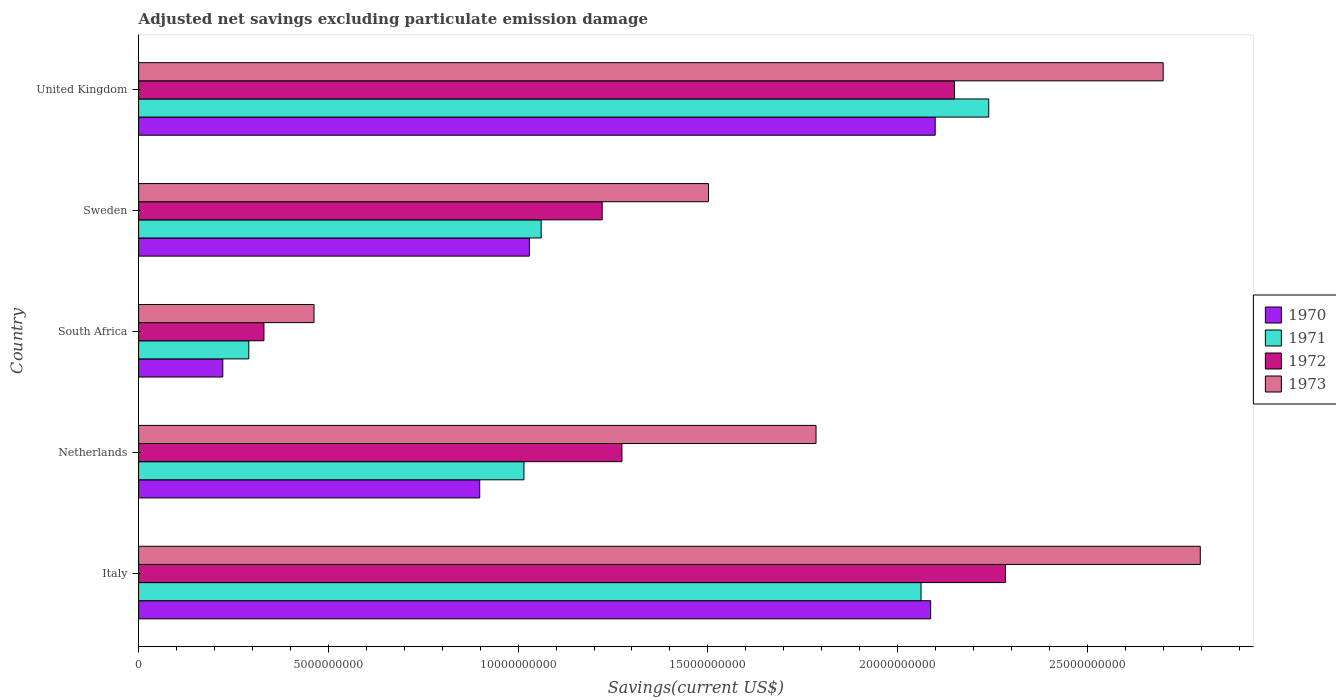How many groups of bars are there?
Give a very brief answer. 5. How many bars are there on the 5th tick from the bottom?
Keep it short and to the point. 4. What is the label of the 2nd group of bars from the top?
Make the answer very short. Sweden. In how many cases, is the number of bars for a given country not equal to the number of legend labels?
Your answer should be compact. 0. What is the adjusted net savings in 1970 in Sweden?
Your answer should be compact. 1.03e+1. Across all countries, what is the maximum adjusted net savings in 1970?
Your response must be concise. 2.10e+1. Across all countries, what is the minimum adjusted net savings in 1971?
Provide a short and direct response. 2.90e+09. In which country was the adjusted net savings in 1972 minimum?
Your response must be concise. South Africa. What is the total adjusted net savings in 1972 in the graph?
Make the answer very short. 7.26e+1. What is the difference between the adjusted net savings in 1970 in Netherlands and that in United Kingdom?
Your answer should be very brief. -1.20e+1. What is the difference between the adjusted net savings in 1970 in Sweden and the adjusted net savings in 1971 in Netherlands?
Make the answer very short. 1.43e+08. What is the average adjusted net savings in 1973 per country?
Your answer should be very brief. 1.85e+1. What is the difference between the adjusted net savings in 1971 and adjusted net savings in 1973 in United Kingdom?
Your response must be concise. -4.60e+09. In how many countries, is the adjusted net savings in 1973 greater than 10000000000 US$?
Provide a succinct answer. 4. What is the ratio of the adjusted net savings in 1970 in Netherlands to that in Sweden?
Offer a terse response. 0.87. Is the adjusted net savings in 1971 in Italy less than that in Netherlands?
Ensure brevity in your answer.  No. What is the difference between the highest and the second highest adjusted net savings in 1973?
Your answer should be compact. 9.78e+08. What is the difference between the highest and the lowest adjusted net savings in 1972?
Your answer should be very brief. 1.95e+1. Is the sum of the adjusted net savings in 1973 in Sweden and United Kingdom greater than the maximum adjusted net savings in 1970 across all countries?
Your answer should be very brief. Yes. What does the 3rd bar from the bottom in Italy represents?
Keep it short and to the point. 1972. How many bars are there?
Keep it short and to the point. 20. How many countries are there in the graph?
Ensure brevity in your answer.  5. What is the difference between two consecutive major ticks on the X-axis?
Your response must be concise. 5.00e+09. Does the graph contain grids?
Keep it short and to the point. No. What is the title of the graph?
Keep it short and to the point. Adjusted net savings excluding particulate emission damage. What is the label or title of the X-axis?
Your answer should be very brief. Savings(current US$). What is the label or title of the Y-axis?
Offer a terse response. Country. What is the Savings(current US$) in 1970 in Italy?
Make the answer very short. 2.09e+1. What is the Savings(current US$) of 1971 in Italy?
Offer a terse response. 2.06e+1. What is the Savings(current US$) in 1972 in Italy?
Your response must be concise. 2.28e+1. What is the Savings(current US$) in 1973 in Italy?
Ensure brevity in your answer.  2.80e+1. What is the Savings(current US$) in 1970 in Netherlands?
Offer a terse response. 8.99e+09. What is the Savings(current US$) of 1971 in Netherlands?
Ensure brevity in your answer.  1.02e+1. What is the Savings(current US$) in 1972 in Netherlands?
Give a very brief answer. 1.27e+1. What is the Savings(current US$) in 1973 in Netherlands?
Provide a short and direct response. 1.79e+1. What is the Savings(current US$) of 1970 in South Africa?
Offer a very short reply. 2.22e+09. What is the Savings(current US$) in 1971 in South Africa?
Provide a short and direct response. 2.90e+09. What is the Savings(current US$) of 1972 in South Africa?
Provide a succinct answer. 3.30e+09. What is the Savings(current US$) in 1973 in South Africa?
Your answer should be very brief. 4.62e+09. What is the Savings(current US$) of 1970 in Sweden?
Your answer should be very brief. 1.03e+1. What is the Savings(current US$) of 1971 in Sweden?
Offer a very short reply. 1.06e+1. What is the Savings(current US$) in 1972 in Sweden?
Keep it short and to the point. 1.22e+1. What is the Savings(current US$) of 1973 in Sweden?
Provide a short and direct response. 1.50e+1. What is the Savings(current US$) of 1970 in United Kingdom?
Provide a short and direct response. 2.10e+1. What is the Savings(current US$) of 1971 in United Kingdom?
Offer a very short reply. 2.24e+1. What is the Savings(current US$) in 1972 in United Kingdom?
Your answer should be very brief. 2.15e+1. What is the Savings(current US$) in 1973 in United Kingdom?
Your answer should be very brief. 2.70e+1. Across all countries, what is the maximum Savings(current US$) in 1970?
Give a very brief answer. 2.10e+1. Across all countries, what is the maximum Savings(current US$) of 1971?
Your answer should be very brief. 2.24e+1. Across all countries, what is the maximum Savings(current US$) of 1972?
Make the answer very short. 2.28e+1. Across all countries, what is the maximum Savings(current US$) in 1973?
Your answer should be compact. 2.80e+1. Across all countries, what is the minimum Savings(current US$) in 1970?
Offer a terse response. 2.22e+09. Across all countries, what is the minimum Savings(current US$) in 1971?
Give a very brief answer. 2.90e+09. Across all countries, what is the minimum Savings(current US$) in 1972?
Provide a short and direct response. 3.30e+09. Across all countries, what is the minimum Savings(current US$) of 1973?
Keep it short and to the point. 4.62e+09. What is the total Savings(current US$) of 1970 in the graph?
Provide a succinct answer. 6.34e+1. What is the total Savings(current US$) in 1971 in the graph?
Offer a terse response. 6.67e+1. What is the total Savings(current US$) in 1972 in the graph?
Provide a succinct answer. 7.26e+1. What is the total Savings(current US$) of 1973 in the graph?
Give a very brief answer. 9.25e+1. What is the difference between the Savings(current US$) in 1970 in Italy and that in Netherlands?
Provide a succinct answer. 1.19e+1. What is the difference between the Savings(current US$) of 1971 in Italy and that in Netherlands?
Your response must be concise. 1.05e+1. What is the difference between the Savings(current US$) in 1972 in Italy and that in Netherlands?
Your response must be concise. 1.01e+1. What is the difference between the Savings(current US$) of 1973 in Italy and that in Netherlands?
Provide a succinct answer. 1.01e+1. What is the difference between the Savings(current US$) in 1970 in Italy and that in South Africa?
Keep it short and to the point. 1.87e+1. What is the difference between the Savings(current US$) in 1971 in Italy and that in South Africa?
Give a very brief answer. 1.77e+1. What is the difference between the Savings(current US$) in 1972 in Italy and that in South Africa?
Your answer should be very brief. 1.95e+1. What is the difference between the Savings(current US$) of 1973 in Italy and that in South Africa?
Offer a very short reply. 2.34e+1. What is the difference between the Savings(current US$) in 1970 in Italy and that in Sweden?
Provide a succinct answer. 1.06e+1. What is the difference between the Savings(current US$) in 1971 in Italy and that in Sweden?
Provide a succinct answer. 1.00e+1. What is the difference between the Savings(current US$) in 1972 in Italy and that in Sweden?
Make the answer very short. 1.06e+1. What is the difference between the Savings(current US$) of 1973 in Italy and that in Sweden?
Provide a short and direct response. 1.30e+1. What is the difference between the Savings(current US$) of 1970 in Italy and that in United Kingdom?
Make the answer very short. -1.20e+08. What is the difference between the Savings(current US$) of 1971 in Italy and that in United Kingdom?
Your answer should be compact. -1.78e+09. What is the difference between the Savings(current US$) of 1972 in Italy and that in United Kingdom?
Your response must be concise. 1.34e+09. What is the difference between the Savings(current US$) of 1973 in Italy and that in United Kingdom?
Provide a succinct answer. 9.78e+08. What is the difference between the Savings(current US$) in 1970 in Netherlands and that in South Africa?
Give a very brief answer. 6.77e+09. What is the difference between the Savings(current US$) in 1971 in Netherlands and that in South Africa?
Provide a short and direct response. 7.25e+09. What is the difference between the Savings(current US$) in 1972 in Netherlands and that in South Africa?
Your response must be concise. 9.43e+09. What is the difference between the Savings(current US$) of 1973 in Netherlands and that in South Africa?
Offer a very short reply. 1.32e+1. What is the difference between the Savings(current US$) in 1970 in Netherlands and that in Sweden?
Give a very brief answer. -1.31e+09. What is the difference between the Savings(current US$) in 1971 in Netherlands and that in Sweden?
Ensure brevity in your answer.  -4.54e+08. What is the difference between the Savings(current US$) in 1972 in Netherlands and that in Sweden?
Your response must be concise. 5.20e+08. What is the difference between the Savings(current US$) in 1973 in Netherlands and that in Sweden?
Ensure brevity in your answer.  2.83e+09. What is the difference between the Savings(current US$) in 1970 in Netherlands and that in United Kingdom?
Your answer should be very brief. -1.20e+1. What is the difference between the Savings(current US$) in 1971 in Netherlands and that in United Kingdom?
Your answer should be very brief. -1.22e+1. What is the difference between the Savings(current US$) in 1972 in Netherlands and that in United Kingdom?
Your answer should be very brief. -8.76e+09. What is the difference between the Savings(current US$) in 1973 in Netherlands and that in United Kingdom?
Your response must be concise. -9.15e+09. What is the difference between the Savings(current US$) of 1970 in South Africa and that in Sweden?
Give a very brief answer. -8.08e+09. What is the difference between the Savings(current US$) of 1971 in South Africa and that in Sweden?
Ensure brevity in your answer.  -7.70e+09. What is the difference between the Savings(current US$) in 1972 in South Africa and that in Sweden?
Give a very brief answer. -8.91e+09. What is the difference between the Savings(current US$) in 1973 in South Africa and that in Sweden?
Your response must be concise. -1.04e+1. What is the difference between the Savings(current US$) of 1970 in South Africa and that in United Kingdom?
Give a very brief answer. -1.88e+1. What is the difference between the Savings(current US$) of 1971 in South Africa and that in United Kingdom?
Keep it short and to the point. -1.95e+1. What is the difference between the Savings(current US$) in 1972 in South Africa and that in United Kingdom?
Provide a succinct answer. -1.82e+1. What is the difference between the Savings(current US$) of 1973 in South Africa and that in United Kingdom?
Your answer should be very brief. -2.24e+1. What is the difference between the Savings(current US$) in 1970 in Sweden and that in United Kingdom?
Keep it short and to the point. -1.07e+1. What is the difference between the Savings(current US$) in 1971 in Sweden and that in United Kingdom?
Give a very brief answer. -1.18e+1. What is the difference between the Savings(current US$) in 1972 in Sweden and that in United Kingdom?
Ensure brevity in your answer.  -9.28e+09. What is the difference between the Savings(current US$) of 1973 in Sweden and that in United Kingdom?
Provide a short and direct response. -1.20e+1. What is the difference between the Savings(current US$) in 1970 in Italy and the Savings(current US$) in 1971 in Netherlands?
Make the answer very short. 1.07e+1. What is the difference between the Savings(current US$) of 1970 in Italy and the Savings(current US$) of 1972 in Netherlands?
Your response must be concise. 8.14e+09. What is the difference between the Savings(current US$) of 1970 in Italy and the Savings(current US$) of 1973 in Netherlands?
Provide a short and direct response. 3.02e+09. What is the difference between the Savings(current US$) in 1971 in Italy and the Savings(current US$) in 1972 in Netherlands?
Offer a very short reply. 7.88e+09. What is the difference between the Savings(current US$) of 1971 in Italy and the Savings(current US$) of 1973 in Netherlands?
Provide a succinct answer. 2.77e+09. What is the difference between the Savings(current US$) in 1972 in Italy and the Savings(current US$) in 1973 in Netherlands?
Ensure brevity in your answer.  4.99e+09. What is the difference between the Savings(current US$) of 1970 in Italy and the Savings(current US$) of 1971 in South Africa?
Give a very brief answer. 1.80e+1. What is the difference between the Savings(current US$) of 1970 in Italy and the Savings(current US$) of 1972 in South Africa?
Your response must be concise. 1.76e+1. What is the difference between the Savings(current US$) of 1970 in Italy and the Savings(current US$) of 1973 in South Africa?
Ensure brevity in your answer.  1.62e+1. What is the difference between the Savings(current US$) in 1971 in Italy and the Savings(current US$) in 1972 in South Africa?
Ensure brevity in your answer.  1.73e+1. What is the difference between the Savings(current US$) in 1971 in Italy and the Savings(current US$) in 1973 in South Africa?
Your answer should be compact. 1.60e+1. What is the difference between the Savings(current US$) of 1972 in Italy and the Savings(current US$) of 1973 in South Africa?
Ensure brevity in your answer.  1.82e+1. What is the difference between the Savings(current US$) of 1970 in Italy and the Savings(current US$) of 1971 in Sweden?
Your response must be concise. 1.03e+1. What is the difference between the Savings(current US$) of 1970 in Italy and the Savings(current US$) of 1972 in Sweden?
Provide a short and direct response. 8.66e+09. What is the difference between the Savings(current US$) in 1970 in Italy and the Savings(current US$) in 1973 in Sweden?
Make the answer very short. 5.85e+09. What is the difference between the Savings(current US$) in 1971 in Italy and the Savings(current US$) in 1972 in Sweden?
Offer a very short reply. 8.40e+09. What is the difference between the Savings(current US$) of 1971 in Italy and the Savings(current US$) of 1973 in Sweden?
Offer a terse response. 5.60e+09. What is the difference between the Savings(current US$) in 1972 in Italy and the Savings(current US$) in 1973 in Sweden?
Ensure brevity in your answer.  7.83e+09. What is the difference between the Savings(current US$) in 1970 in Italy and the Savings(current US$) in 1971 in United Kingdom?
Keep it short and to the point. -1.53e+09. What is the difference between the Savings(current US$) in 1970 in Italy and the Savings(current US$) in 1972 in United Kingdom?
Keep it short and to the point. -6.28e+08. What is the difference between the Savings(current US$) in 1970 in Italy and the Savings(current US$) in 1973 in United Kingdom?
Your answer should be very brief. -6.13e+09. What is the difference between the Savings(current US$) of 1971 in Italy and the Savings(current US$) of 1972 in United Kingdom?
Offer a terse response. -8.80e+08. What is the difference between the Savings(current US$) in 1971 in Italy and the Savings(current US$) in 1973 in United Kingdom?
Make the answer very short. -6.38e+09. What is the difference between the Savings(current US$) in 1972 in Italy and the Savings(current US$) in 1973 in United Kingdom?
Give a very brief answer. -4.15e+09. What is the difference between the Savings(current US$) in 1970 in Netherlands and the Savings(current US$) in 1971 in South Africa?
Provide a succinct answer. 6.09e+09. What is the difference between the Savings(current US$) in 1970 in Netherlands and the Savings(current US$) in 1972 in South Africa?
Make the answer very short. 5.69e+09. What is the difference between the Savings(current US$) of 1970 in Netherlands and the Savings(current US$) of 1973 in South Africa?
Ensure brevity in your answer.  4.37e+09. What is the difference between the Savings(current US$) of 1971 in Netherlands and the Savings(current US$) of 1972 in South Africa?
Provide a succinct answer. 6.85e+09. What is the difference between the Savings(current US$) in 1971 in Netherlands and the Savings(current US$) in 1973 in South Africa?
Offer a terse response. 5.53e+09. What is the difference between the Savings(current US$) in 1972 in Netherlands and the Savings(current US$) in 1973 in South Africa?
Your answer should be very brief. 8.11e+09. What is the difference between the Savings(current US$) in 1970 in Netherlands and the Savings(current US$) in 1971 in Sweden?
Make the answer very short. -1.62e+09. What is the difference between the Savings(current US$) in 1970 in Netherlands and the Savings(current US$) in 1972 in Sweden?
Offer a terse response. -3.23e+09. What is the difference between the Savings(current US$) of 1970 in Netherlands and the Savings(current US$) of 1973 in Sweden?
Make the answer very short. -6.03e+09. What is the difference between the Savings(current US$) in 1971 in Netherlands and the Savings(current US$) in 1972 in Sweden?
Offer a very short reply. -2.06e+09. What is the difference between the Savings(current US$) of 1971 in Netherlands and the Savings(current US$) of 1973 in Sweden?
Your answer should be very brief. -4.86e+09. What is the difference between the Savings(current US$) of 1972 in Netherlands and the Savings(current US$) of 1973 in Sweden?
Keep it short and to the point. -2.28e+09. What is the difference between the Savings(current US$) of 1970 in Netherlands and the Savings(current US$) of 1971 in United Kingdom?
Offer a terse response. -1.34e+1. What is the difference between the Savings(current US$) of 1970 in Netherlands and the Savings(current US$) of 1972 in United Kingdom?
Make the answer very short. -1.25e+1. What is the difference between the Savings(current US$) of 1970 in Netherlands and the Savings(current US$) of 1973 in United Kingdom?
Ensure brevity in your answer.  -1.80e+1. What is the difference between the Savings(current US$) in 1971 in Netherlands and the Savings(current US$) in 1972 in United Kingdom?
Provide a succinct answer. -1.13e+1. What is the difference between the Savings(current US$) in 1971 in Netherlands and the Savings(current US$) in 1973 in United Kingdom?
Offer a terse response. -1.68e+1. What is the difference between the Savings(current US$) in 1972 in Netherlands and the Savings(current US$) in 1973 in United Kingdom?
Give a very brief answer. -1.43e+1. What is the difference between the Savings(current US$) of 1970 in South Africa and the Savings(current US$) of 1971 in Sweden?
Give a very brief answer. -8.39e+09. What is the difference between the Savings(current US$) in 1970 in South Africa and the Savings(current US$) in 1972 in Sweden?
Provide a succinct answer. -1.00e+1. What is the difference between the Savings(current US$) of 1970 in South Africa and the Savings(current US$) of 1973 in Sweden?
Offer a terse response. -1.28e+1. What is the difference between the Savings(current US$) of 1971 in South Africa and the Savings(current US$) of 1972 in Sweden?
Provide a short and direct response. -9.31e+09. What is the difference between the Savings(current US$) of 1971 in South Africa and the Savings(current US$) of 1973 in Sweden?
Provide a short and direct response. -1.21e+1. What is the difference between the Savings(current US$) in 1972 in South Africa and the Savings(current US$) in 1973 in Sweden?
Your answer should be compact. -1.17e+1. What is the difference between the Savings(current US$) of 1970 in South Africa and the Savings(current US$) of 1971 in United Kingdom?
Ensure brevity in your answer.  -2.02e+1. What is the difference between the Savings(current US$) of 1970 in South Africa and the Savings(current US$) of 1972 in United Kingdom?
Your response must be concise. -1.93e+1. What is the difference between the Savings(current US$) in 1970 in South Africa and the Savings(current US$) in 1973 in United Kingdom?
Offer a very short reply. -2.48e+1. What is the difference between the Savings(current US$) in 1971 in South Africa and the Savings(current US$) in 1972 in United Kingdom?
Your answer should be very brief. -1.86e+1. What is the difference between the Savings(current US$) of 1971 in South Africa and the Savings(current US$) of 1973 in United Kingdom?
Provide a short and direct response. -2.41e+1. What is the difference between the Savings(current US$) of 1972 in South Africa and the Savings(current US$) of 1973 in United Kingdom?
Give a very brief answer. -2.37e+1. What is the difference between the Savings(current US$) of 1970 in Sweden and the Savings(current US$) of 1971 in United Kingdom?
Your answer should be compact. -1.21e+1. What is the difference between the Savings(current US$) in 1970 in Sweden and the Savings(current US$) in 1972 in United Kingdom?
Give a very brief answer. -1.12e+1. What is the difference between the Savings(current US$) of 1970 in Sweden and the Savings(current US$) of 1973 in United Kingdom?
Make the answer very short. -1.67e+1. What is the difference between the Savings(current US$) of 1971 in Sweden and the Savings(current US$) of 1972 in United Kingdom?
Ensure brevity in your answer.  -1.09e+1. What is the difference between the Savings(current US$) in 1971 in Sweden and the Savings(current US$) in 1973 in United Kingdom?
Provide a succinct answer. -1.64e+1. What is the difference between the Savings(current US$) of 1972 in Sweden and the Savings(current US$) of 1973 in United Kingdom?
Keep it short and to the point. -1.48e+1. What is the average Savings(current US$) in 1970 per country?
Make the answer very short. 1.27e+1. What is the average Savings(current US$) of 1971 per country?
Offer a very short reply. 1.33e+1. What is the average Savings(current US$) of 1972 per country?
Provide a succinct answer. 1.45e+1. What is the average Savings(current US$) of 1973 per country?
Ensure brevity in your answer.  1.85e+1. What is the difference between the Savings(current US$) in 1970 and Savings(current US$) in 1971 in Italy?
Ensure brevity in your answer.  2.53e+08. What is the difference between the Savings(current US$) in 1970 and Savings(current US$) in 1972 in Italy?
Your answer should be compact. -1.97e+09. What is the difference between the Savings(current US$) of 1970 and Savings(current US$) of 1973 in Italy?
Make the answer very short. -7.11e+09. What is the difference between the Savings(current US$) of 1971 and Savings(current US$) of 1972 in Italy?
Provide a short and direct response. -2.23e+09. What is the difference between the Savings(current US$) of 1971 and Savings(current US$) of 1973 in Italy?
Ensure brevity in your answer.  -7.36e+09. What is the difference between the Savings(current US$) of 1972 and Savings(current US$) of 1973 in Italy?
Make the answer very short. -5.13e+09. What is the difference between the Savings(current US$) in 1970 and Savings(current US$) in 1971 in Netherlands?
Keep it short and to the point. -1.17e+09. What is the difference between the Savings(current US$) of 1970 and Savings(current US$) of 1972 in Netherlands?
Give a very brief answer. -3.75e+09. What is the difference between the Savings(current US$) in 1970 and Savings(current US$) in 1973 in Netherlands?
Your answer should be compact. -8.86e+09. What is the difference between the Savings(current US$) of 1971 and Savings(current US$) of 1972 in Netherlands?
Give a very brief answer. -2.58e+09. What is the difference between the Savings(current US$) in 1971 and Savings(current US$) in 1973 in Netherlands?
Make the answer very short. -7.70e+09. What is the difference between the Savings(current US$) of 1972 and Savings(current US$) of 1973 in Netherlands?
Your answer should be compact. -5.11e+09. What is the difference between the Savings(current US$) of 1970 and Savings(current US$) of 1971 in South Africa?
Provide a short and direct response. -6.85e+08. What is the difference between the Savings(current US$) of 1970 and Savings(current US$) of 1972 in South Africa?
Your answer should be compact. -1.08e+09. What is the difference between the Savings(current US$) of 1970 and Savings(current US$) of 1973 in South Africa?
Provide a succinct answer. -2.40e+09. What is the difference between the Savings(current US$) of 1971 and Savings(current US$) of 1972 in South Africa?
Your response must be concise. -4.00e+08. What is the difference between the Savings(current US$) of 1971 and Savings(current US$) of 1973 in South Africa?
Keep it short and to the point. -1.72e+09. What is the difference between the Savings(current US$) of 1972 and Savings(current US$) of 1973 in South Africa?
Give a very brief answer. -1.32e+09. What is the difference between the Savings(current US$) of 1970 and Savings(current US$) of 1971 in Sweden?
Your answer should be very brief. -3.10e+08. What is the difference between the Savings(current US$) of 1970 and Savings(current US$) of 1972 in Sweden?
Keep it short and to the point. -1.92e+09. What is the difference between the Savings(current US$) of 1970 and Savings(current US$) of 1973 in Sweden?
Your answer should be very brief. -4.72e+09. What is the difference between the Savings(current US$) of 1971 and Savings(current US$) of 1972 in Sweden?
Your answer should be very brief. -1.61e+09. What is the difference between the Savings(current US$) of 1971 and Savings(current US$) of 1973 in Sweden?
Give a very brief answer. -4.41e+09. What is the difference between the Savings(current US$) of 1972 and Savings(current US$) of 1973 in Sweden?
Give a very brief answer. -2.80e+09. What is the difference between the Savings(current US$) of 1970 and Savings(current US$) of 1971 in United Kingdom?
Your response must be concise. -1.41e+09. What is the difference between the Savings(current US$) in 1970 and Savings(current US$) in 1972 in United Kingdom?
Your answer should be compact. -5.08e+08. What is the difference between the Savings(current US$) in 1970 and Savings(current US$) in 1973 in United Kingdom?
Your answer should be compact. -6.01e+09. What is the difference between the Savings(current US$) of 1971 and Savings(current US$) of 1972 in United Kingdom?
Keep it short and to the point. 9.03e+08. What is the difference between the Savings(current US$) of 1971 and Savings(current US$) of 1973 in United Kingdom?
Make the answer very short. -4.60e+09. What is the difference between the Savings(current US$) in 1972 and Savings(current US$) in 1973 in United Kingdom?
Give a very brief answer. -5.50e+09. What is the ratio of the Savings(current US$) of 1970 in Italy to that in Netherlands?
Keep it short and to the point. 2.32. What is the ratio of the Savings(current US$) in 1971 in Italy to that in Netherlands?
Your response must be concise. 2.03. What is the ratio of the Savings(current US$) of 1972 in Italy to that in Netherlands?
Your response must be concise. 1.79. What is the ratio of the Savings(current US$) in 1973 in Italy to that in Netherlands?
Give a very brief answer. 1.57. What is the ratio of the Savings(current US$) in 1970 in Italy to that in South Africa?
Offer a terse response. 9.41. What is the ratio of the Savings(current US$) of 1971 in Italy to that in South Africa?
Your response must be concise. 7.1. What is the ratio of the Savings(current US$) of 1972 in Italy to that in South Africa?
Offer a terse response. 6.92. What is the ratio of the Savings(current US$) of 1973 in Italy to that in South Africa?
Ensure brevity in your answer.  6.05. What is the ratio of the Savings(current US$) in 1970 in Italy to that in Sweden?
Give a very brief answer. 2.03. What is the ratio of the Savings(current US$) in 1971 in Italy to that in Sweden?
Provide a short and direct response. 1.94. What is the ratio of the Savings(current US$) in 1972 in Italy to that in Sweden?
Keep it short and to the point. 1.87. What is the ratio of the Savings(current US$) in 1973 in Italy to that in Sweden?
Offer a terse response. 1.86. What is the ratio of the Savings(current US$) in 1971 in Italy to that in United Kingdom?
Give a very brief answer. 0.92. What is the ratio of the Savings(current US$) of 1972 in Italy to that in United Kingdom?
Provide a succinct answer. 1.06. What is the ratio of the Savings(current US$) in 1973 in Italy to that in United Kingdom?
Your response must be concise. 1.04. What is the ratio of the Savings(current US$) in 1970 in Netherlands to that in South Africa?
Provide a succinct answer. 4.05. What is the ratio of the Savings(current US$) of 1971 in Netherlands to that in South Africa?
Your response must be concise. 3.5. What is the ratio of the Savings(current US$) of 1972 in Netherlands to that in South Africa?
Give a very brief answer. 3.86. What is the ratio of the Savings(current US$) of 1973 in Netherlands to that in South Africa?
Keep it short and to the point. 3.86. What is the ratio of the Savings(current US$) of 1970 in Netherlands to that in Sweden?
Your answer should be very brief. 0.87. What is the ratio of the Savings(current US$) in 1971 in Netherlands to that in Sweden?
Offer a very short reply. 0.96. What is the ratio of the Savings(current US$) in 1972 in Netherlands to that in Sweden?
Offer a terse response. 1.04. What is the ratio of the Savings(current US$) of 1973 in Netherlands to that in Sweden?
Your answer should be compact. 1.19. What is the ratio of the Savings(current US$) in 1970 in Netherlands to that in United Kingdom?
Your response must be concise. 0.43. What is the ratio of the Savings(current US$) in 1971 in Netherlands to that in United Kingdom?
Make the answer very short. 0.45. What is the ratio of the Savings(current US$) in 1972 in Netherlands to that in United Kingdom?
Keep it short and to the point. 0.59. What is the ratio of the Savings(current US$) of 1973 in Netherlands to that in United Kingdom?
Ensure brevity in your answer.  0.66. What is the ratio of the Savings(current US$) in 1970 in South Africa to that in Sweden?
Ensure brevity in your answer.  0.22. What is the ratio of the Savings(current US$) of 1971 in South Africa to that in Sweden?
Ensure brevity in your answer.  0.27. What is the ratio of the Savings(current US$) in 1972 in South Africa to that in Sweden?
Give a very brief answer. 0.27. What is the ratio of the Savings(current US$) of 1973 in South Africa to that in Sweden?
Offer a terse response. 0.31. What is the ratio of the Savings(current US$) of 1970 in South Africa to that in United Kingdom?
Your response must be concise. 0.11. What is the ratio of the Savings(current US$) in 1971 in South Africa to that in United Kingdom?
Ensure brevity in your answer.  0.13. What is the ratio of the Savings(current US$) in 1972 in South Africa to that in United Kingdom?
Provide a succinct answer. 0.15. What is the ratio of the Savings(current US$) of 1973 in South Africa to that in United Kingdom?
Your answer should be very brief. 0.17. What is the ratio of the Savings(current US$) in 1970 in Sweden to that in United Kingdom?
Make the answer very short. 0.49. What is the ratio of the Savings(current US$) of 1971 in Sweden to that in United Kingdom?
Give a very brief answer. 0.47. What is the ratio of the Savings(current US$) of 1972 in Sweden to that in United Kingdom?
Give a very brief answer. 0.57. What is the ratio of the Savings(current US$) of 1973 in Sweden to that in United Kingdom?
Your answer should be compact. 0.56. What is the difference between the highest and the second highest Savings(current US$) of 1970?
Your answer should be compact. 1.20e+08. What is the difference between the highest and the second highest Savings(current US$) of 1971?
Keep it short and to the point. 1.78e+09. What is the difference between the highest and the second highest Savings(current US$) of 1972?
Offer a terse response. 1.34e+09. What is the difference between the highest and the second highest Savings(current US$) in 1973?
Offer a terse response. 9.78e+08. What is the difference between the highest and the lowest Savings(current US$) in 1970?
Give a very brief answer. 1.88e+1. What is the difference between the highest and the lowest Savings(current US$) of 1971?
Keep it short and to the point. 1.95e+1. What is the difference between the highest and the lowest Savings(current US$) of 1972?
Your answer should be very brief. 1.95e+1. What is the difference between the highest and the lowest Savings(current US$) of 1973?
Offer a terse response. 2.34e+1. 